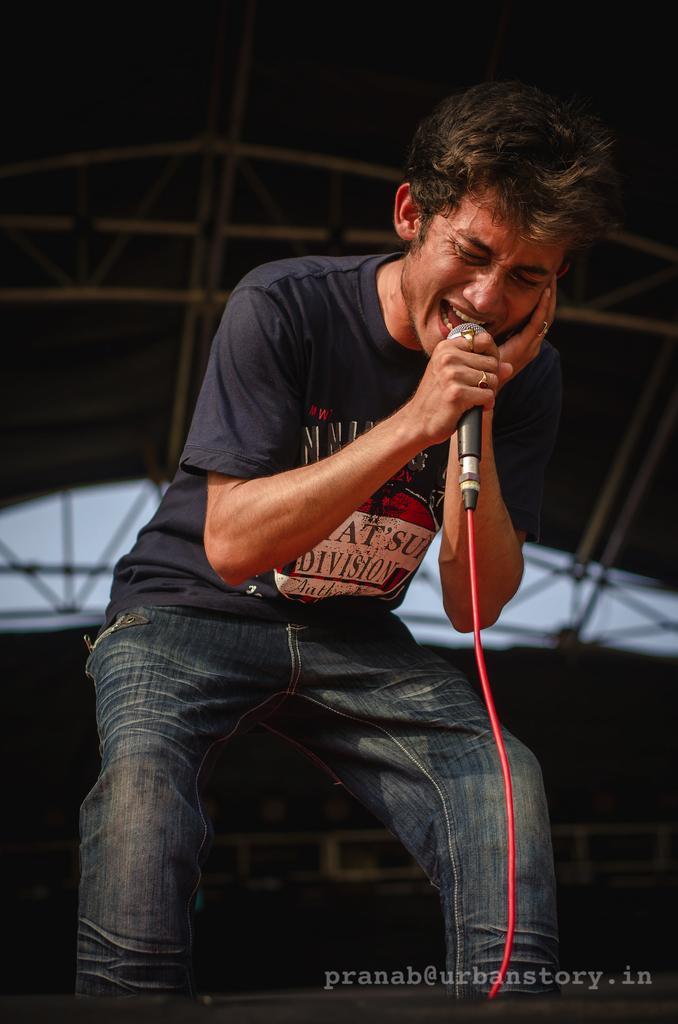Describe this image in one or two sentences. In this picture a man is singing with the help of microphone, in the background we can see couple of metal rods. 